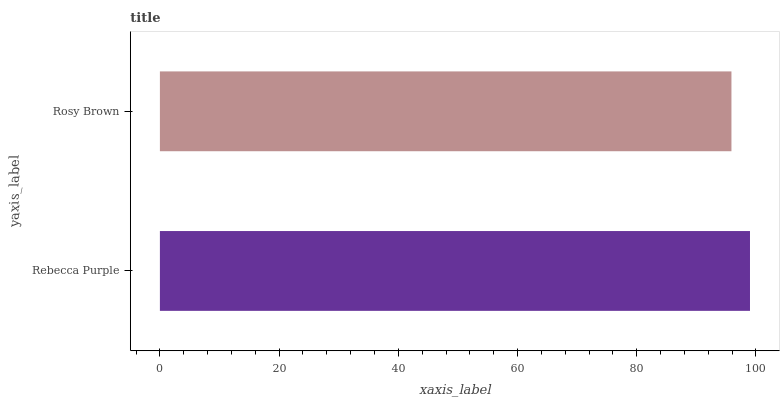Is Rosy Brown the minimum?
Answer yes or no. Yes. Is Rebecca Purple the maximum?
Answer yes or no. Yes. Is Rosy Brown the maximum?
Answer yes or no. No. Is Rebecca Purple greater than Rosy Brown?
Answer yes or no. Yes. Is Rosy Brown less than Rebecca Purple?
Answer yes or no. Yes. Is Rosy Brown greater than Rebecca Purple?
Answer yes or no. No. Is Rebecca Purple less than Rosy Brown?
Answer yes or no. No. Is Rebecca Purple the high median?
Answer yes or no. Yes. Is Rosy Brown the low median?
Answer yes or no. Yes. Is Rosy Brown the high median?
Answer yes or no. No. Is Rebecca Purple the low median?
Answer yes or no. No. 